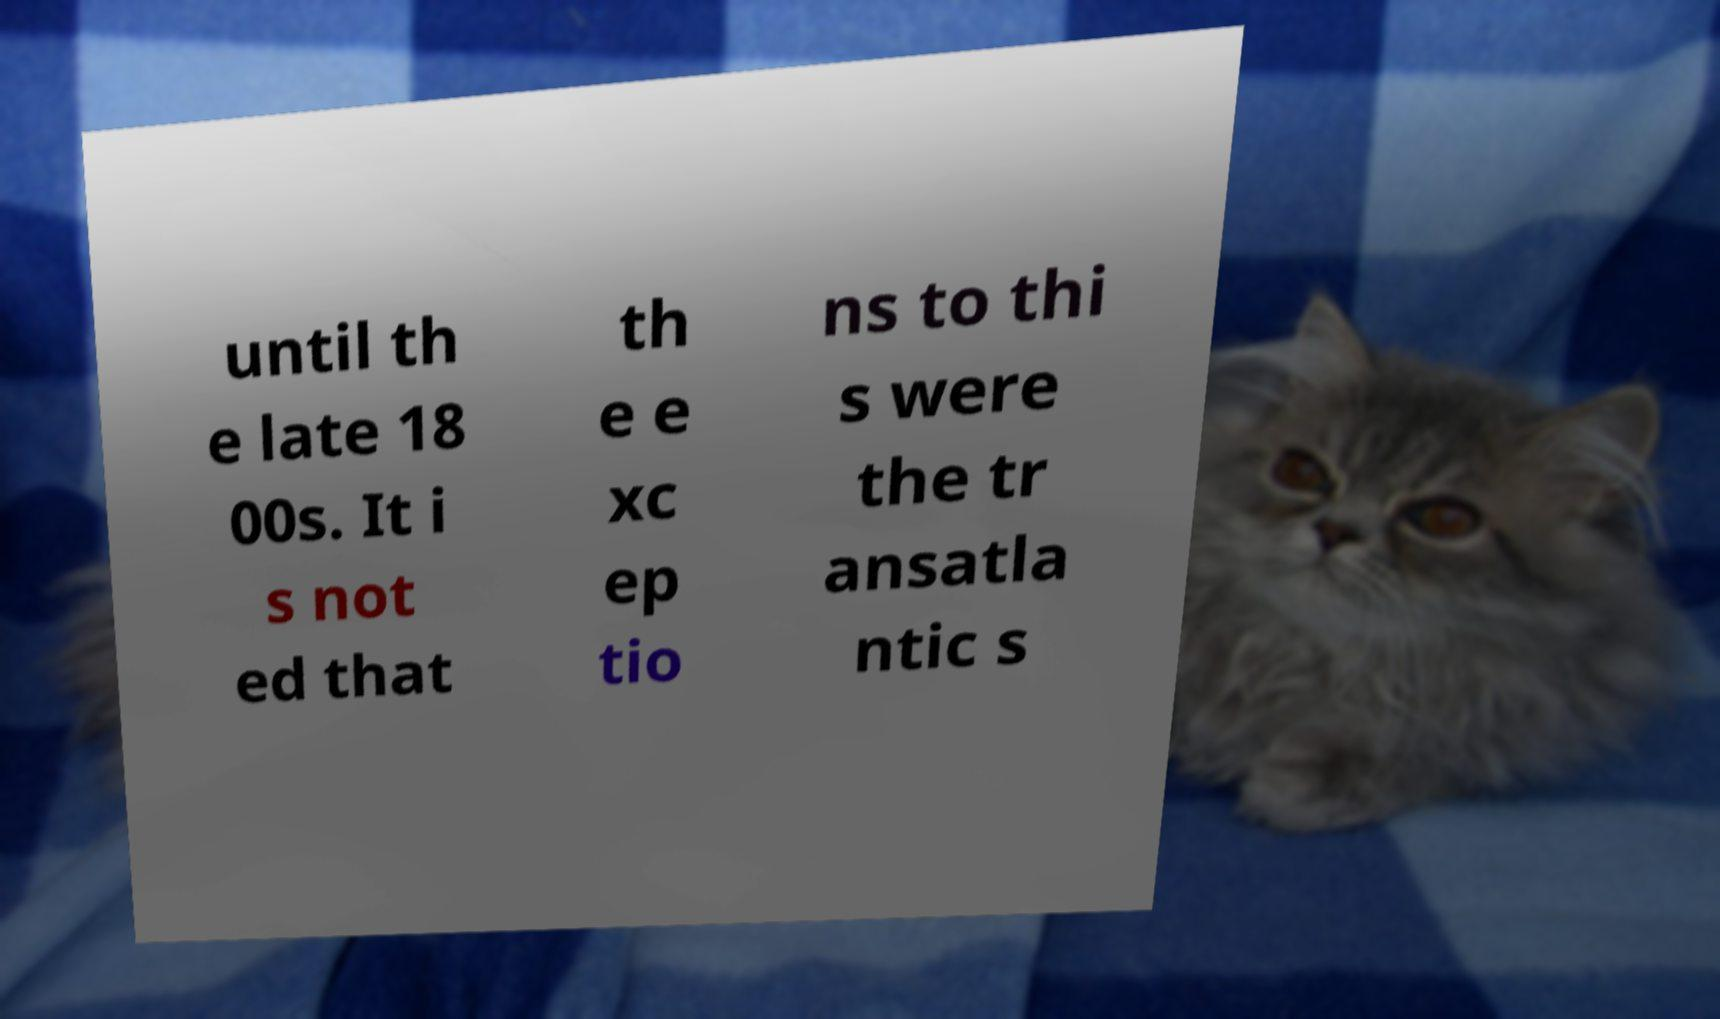There's text embedded in this image that I need extracted. Can you transcribe it verbatim? until th e late 18 00s. It i s not ed that th e e xc ep tio ns to thi s were the tr ansatla ntic s 